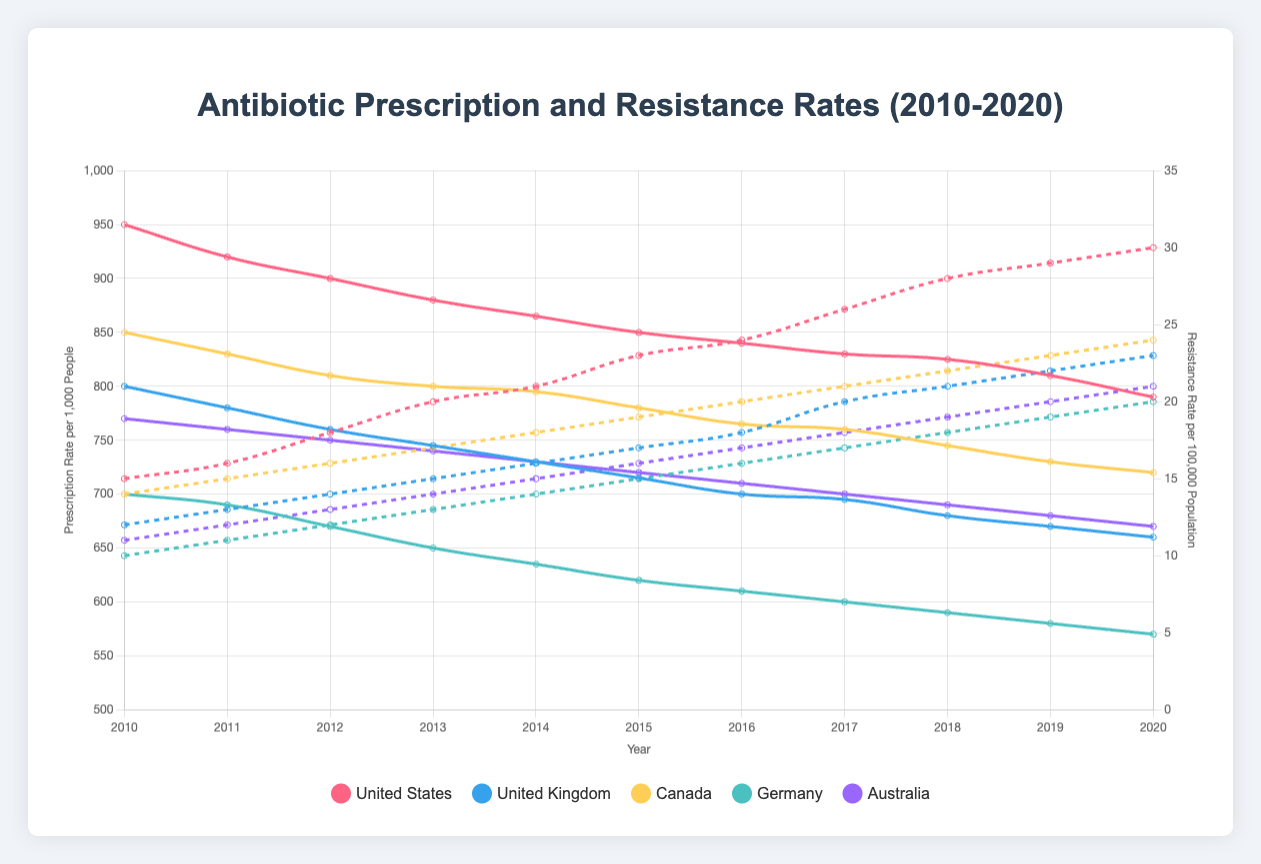Which country had the highest antibiotic prescription rate in 2010? Looking at the line corresponding to 2010, we see that the United States line is at the highest position, indicating the highest antibiotic prescription rate.
Answer: United States Which country shows the largest decrease in antibiotic prescription rate from 2010 to 2020? To find the largest decrease, we need to compare the difference between the 2010 and 2020 values for each country. The United States dropped from 950 to 790, a decrease of 160, which appears to be the largest.
Answer: United States What is the average antibiotic resistance rate in Germany over the decade? We sum the resistance rates for Germany over the decade (10 + 11 + 12 + 13 + 14 + 15 + 16 + 17 + 18 + 19 + 20 = 165) and divide by the number of years (11). The average is 165 / 11 ≈ 15.
Answer: 15 Did any country's antibiotic resistance rate decrease at any point during the decade? By visually tracing the resistance rate lines for each country, we see that no line dips downward at any point; they all show a consistent upward trend.
Answer: No How does the antibiotic resistance rate in Australia in 2020 compare to the rate in Canada in the same year? In 2020, Australia's resistance rate is 21, while Canada's is 24, meaning Canada's rate is higher.
Answer: Canada's is higher Which country had the lowest antibiotic resistance rate in 2015? Looking at the intersections of the resistance rate lines with 2015, Germany's line is the lowest, indicating the lowest resistance rate.
Answer: Germany What is the total decline in antibiotic prescription rate in the United Kingdom from 2010 to 2020? The UK’s rate in 2010 was 800, and it was 660 in 2020. The total decline is 800 - 660 = 140.
Answer: 140 Among the countries observed, which had the slowest increase in antibiotic resistance rate from 2010 to 2020? By calculating the increase for each country (2020 value minus 2010 value), we find:
- United States: 30 - 15 = 15
- United Kingdom: 23 - 12 = 11
- Canada: 24 - 14 = 10
- Germany: 20 - 10 = 10
- Australia: 21 - 11 = 10
Thus, Canada, Germany, and Australia all have the smallest increase of 10.
Answer: Canada, Germany, Australia Is there any country where the antibiotic prescription rate and resistance rate both increased from 2010 to 2020? By tracing both prescription and resistance lines, no country shows an increase in both metrics. Prescription rates decrease for all countries.
Answer: No How did the overall trend in antibiotic prescription rates change over the decade for Australia? The prescription rate for Australia shows a steady decline from 770 in 2010 to 670 in 2020, indicating a downward trend.
Answer: Downward 